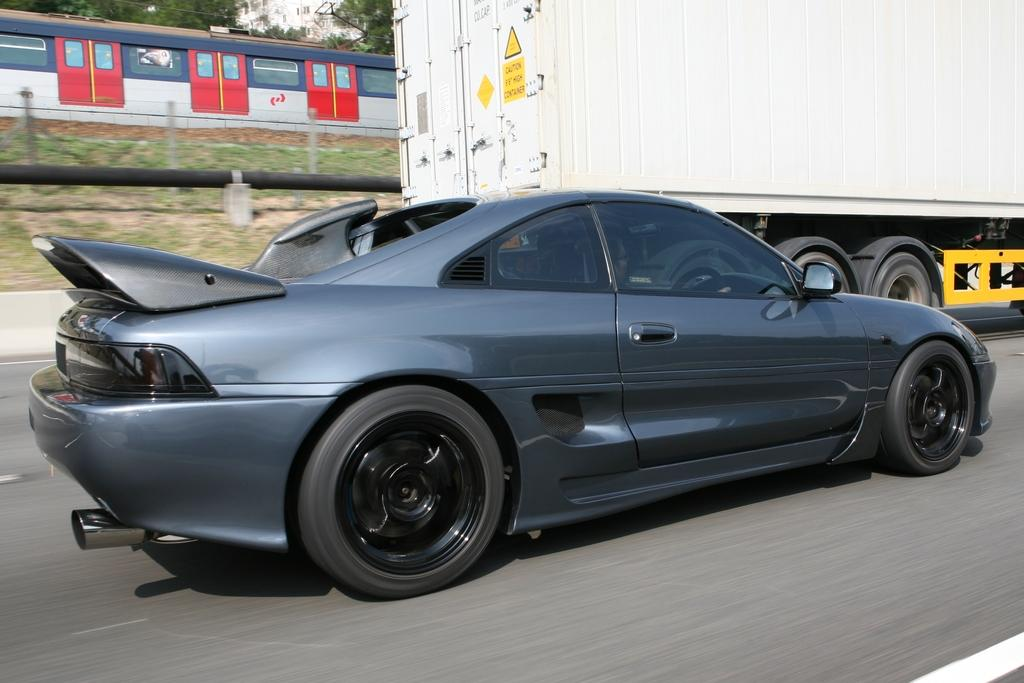What type of vehicles can be seen in the image? There is a car and a truck in the image. Where are the vehicles located? Both the car and truck are on the road in the image. What other structures or objects can be seen in the image? There is a fence, a pole, grass, a train on the track, and trees visible in the image. What type of pollution is visible in the image? There is no visible pollution in the image. What type of work is being done by the train in the image? The train is not performing any work in the image; it is simply on the track. 